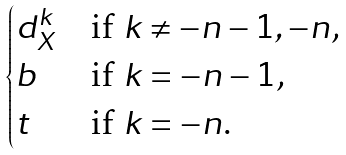Convert formula to latex. <formula><loc_0><loc_0><loc_500><loc_500>\begin{cases} d _ { X } ^ { k } & \text {if $k \ne -n-1, -n$,} \\ b & \text {if $k = -n-1$,} \\ t & \text {if $k = -n$.} \end{cases}</formula> 